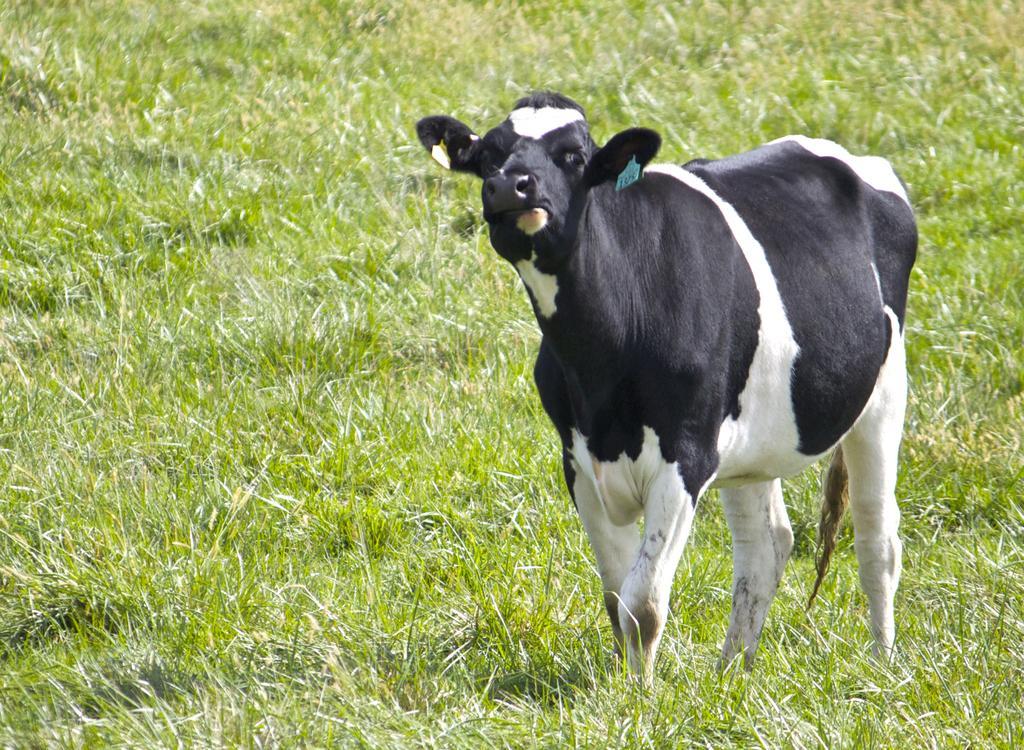Describe this image in one or two sentences. There is a black and white cow with tags on the ears. On the ground there is grass. 